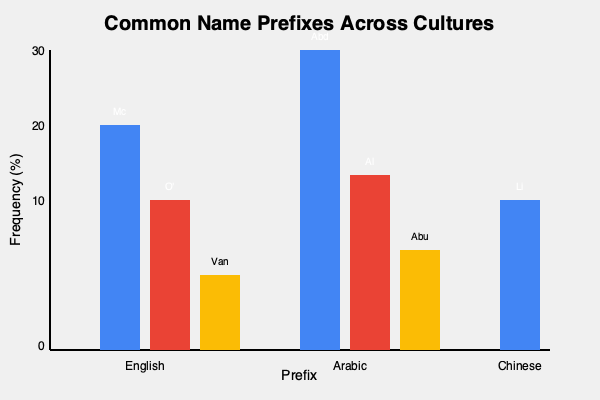Based on the bar chart comparing common name prefixes across different cultures, which culture shows the highest frequency for a single prefix, and what is that prefix? To answer this question, we need to analyze the bar chart and compare the heights of the bars for each culture:

1. English prefixes:
   - Mc: approximately 22.5%
   - O': approximately 15%
   - Van: approximately 7.5%

2. Arabic prefixes:
   - Abd: 30%
   - Al: approximately 17.5%
   - Abu: 10%

3. Chinese prefix:
   - Li: 15%

The highest bar in the chart represents the prefix with the highest frequency. This bar is in the Arabic section and corresponds to the prefix "Abd" at 30%.

To confirm:
- The highest English prefix (Mc) is lower than Abd.
- The other Arabic prefixes (Al and Abu) are lower than Abd.
- The Chinese prefix (Li) is much lower than Abd.

Therefore, the culture with the highest frequency for a single prefix is Arabic, and the prefix is "Abd" at 30%.
Answer: Arabic, Abd 